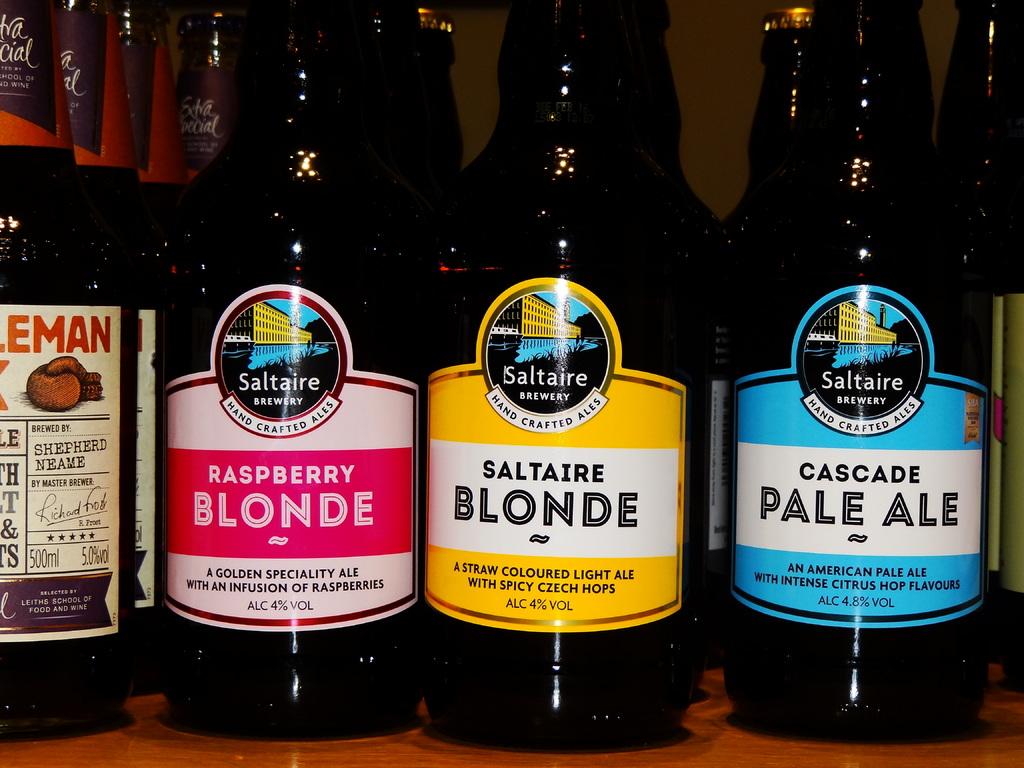What is the name of the blue labeled bottle?
Keep it short and to the point. Cascade pale ale. What type of berry is mentioned on the red bottle?
Offer a terse response. Raspberry. 